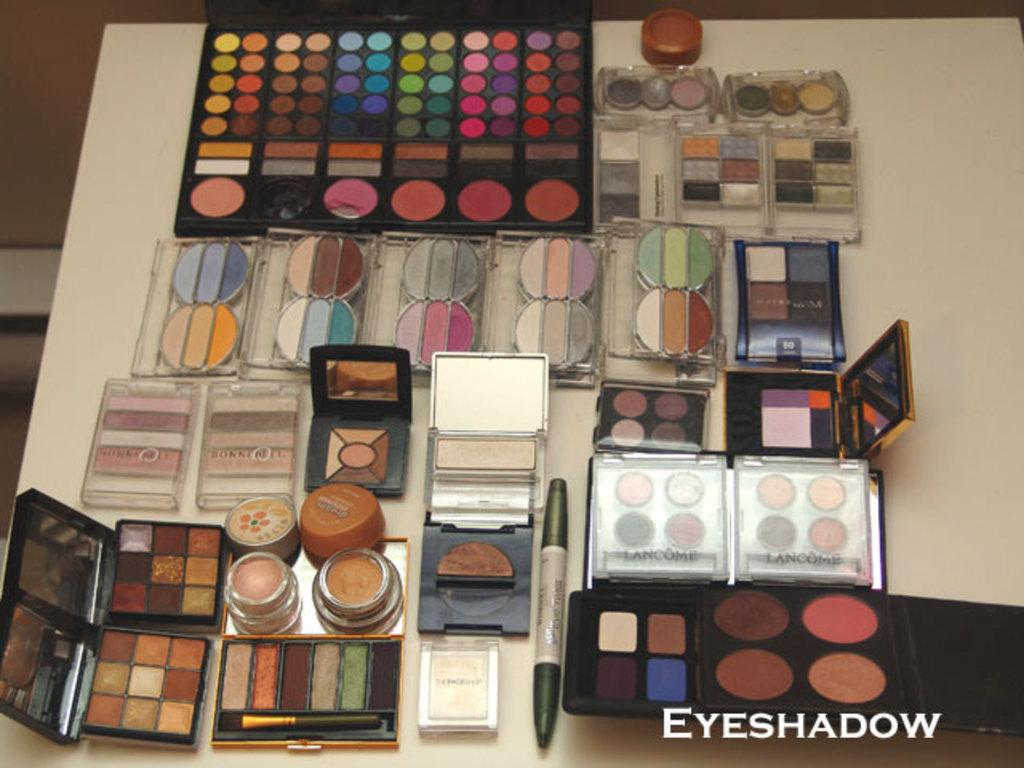What is the main object in the center of the image? There is a table in the center of the image. What items can be seen on the table? There are mirrors, an eyeliner, a brush, makeup cosmetics, and eye shades with different colors on the table. What type of makeup tool is present on the table? There is an eyeliner and a brush on the table. How many different colors of eye shades are on the table? There are eye shades with different colors on the table. Can you tell me how many volleyballs are on the table in the image? There are no volleyballs present on the table in the image. What type of paper is used to create the eye shades on the table? There is no paper mentioned or visible in the image; the eye shades are made of a different material. 